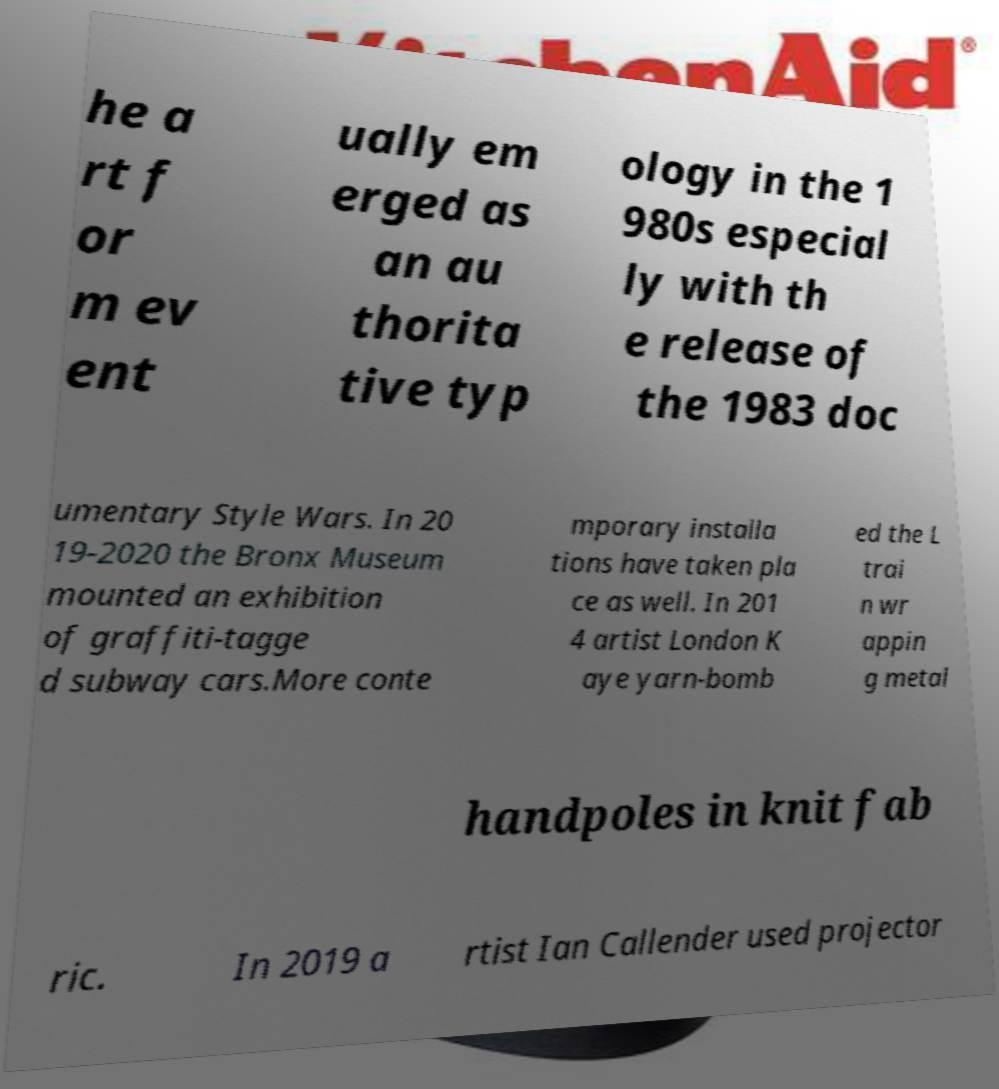I need the written content from this picture converted into text. Can you do that? he a rt f or m ev ent ually em erged as an au thorita tive typ ology in the 1 980s especial ly with th e release of the 1983 doc umentary Style Wars. In 20 19-2020 the Bronx Museum mounted an exhibition of graffiti-tagge d subway cars.More conte mporary installa tions have taken pla ce as well. In 201 4 artist London K aye yarn-bomb ed the L trai n wr appin g metal handpoles in knit fab ric. In 2019 a rtist Ian Callender used projector 